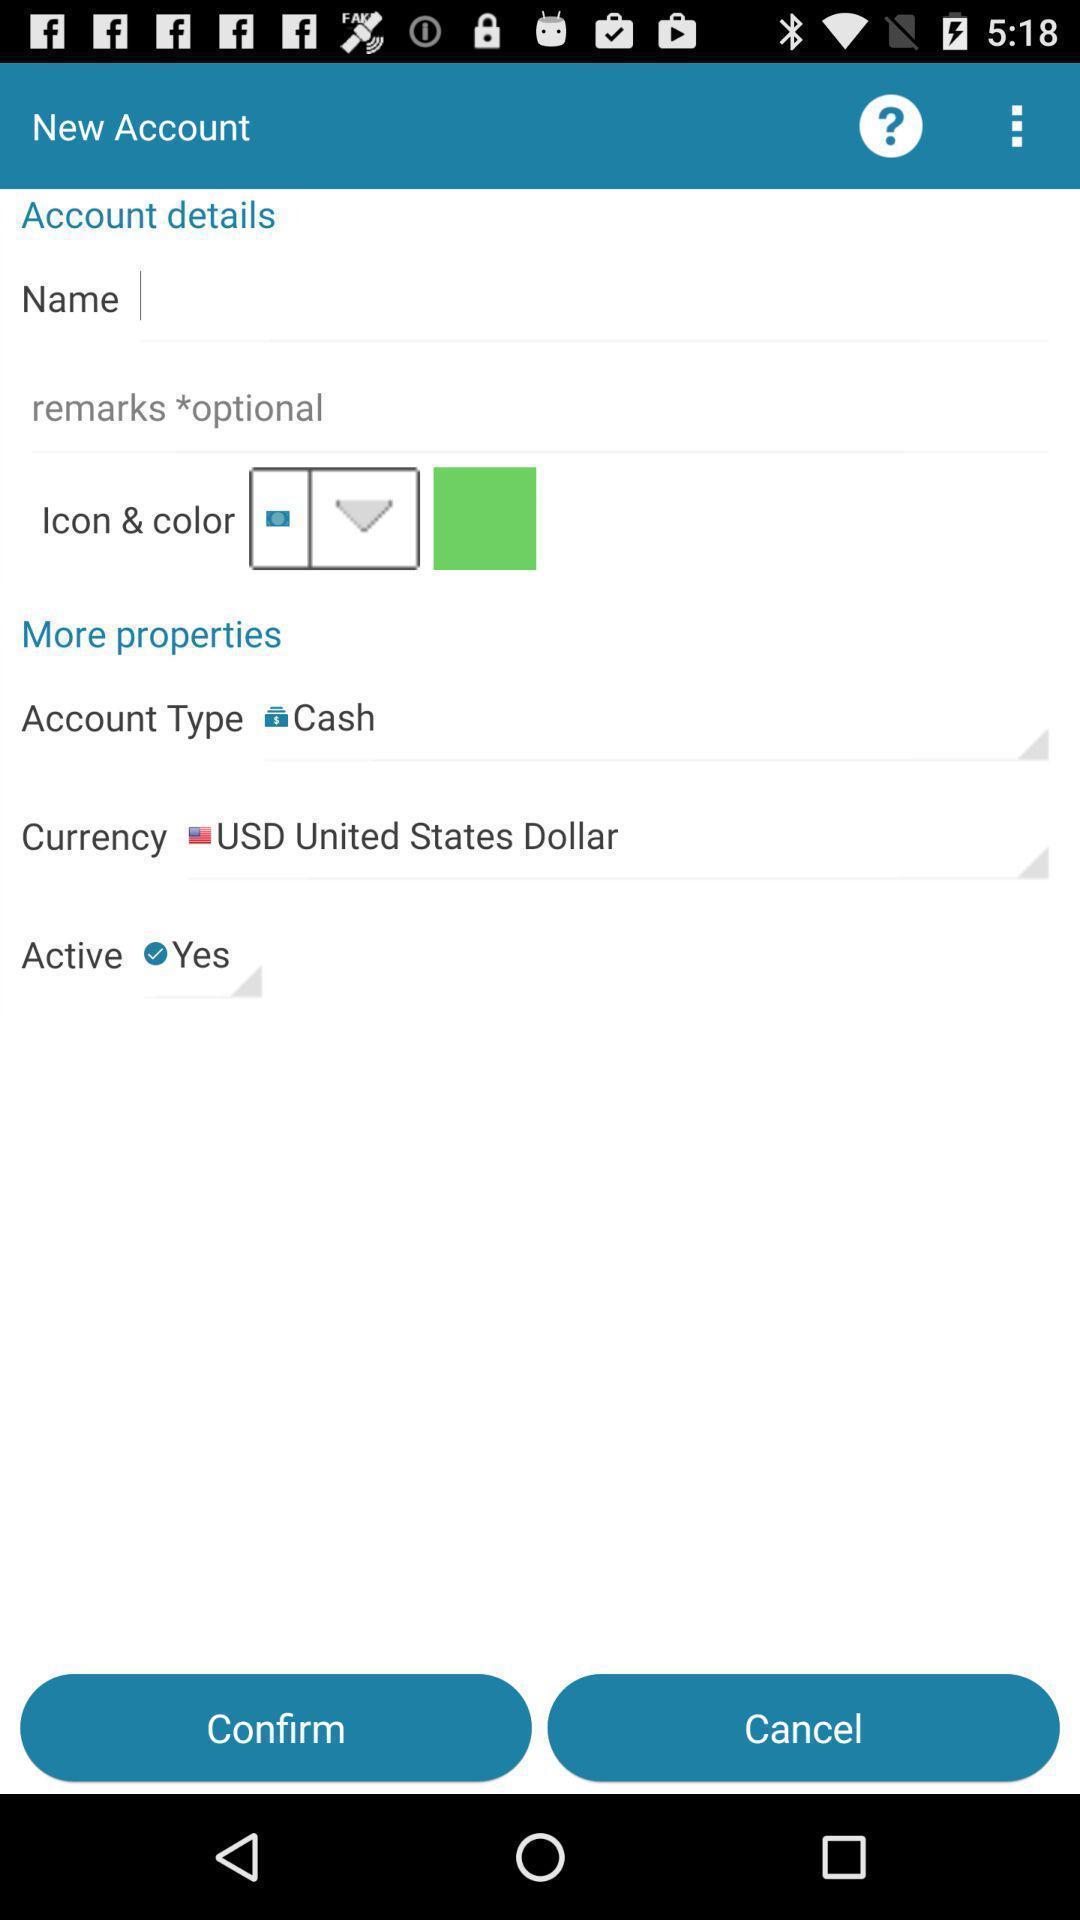Explain the elements present in this screenshot. Page showing setting options in a finance management app. 